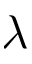<formula> <loc_0><loc_0><loc_500><loc_500>\lambda</formula> 